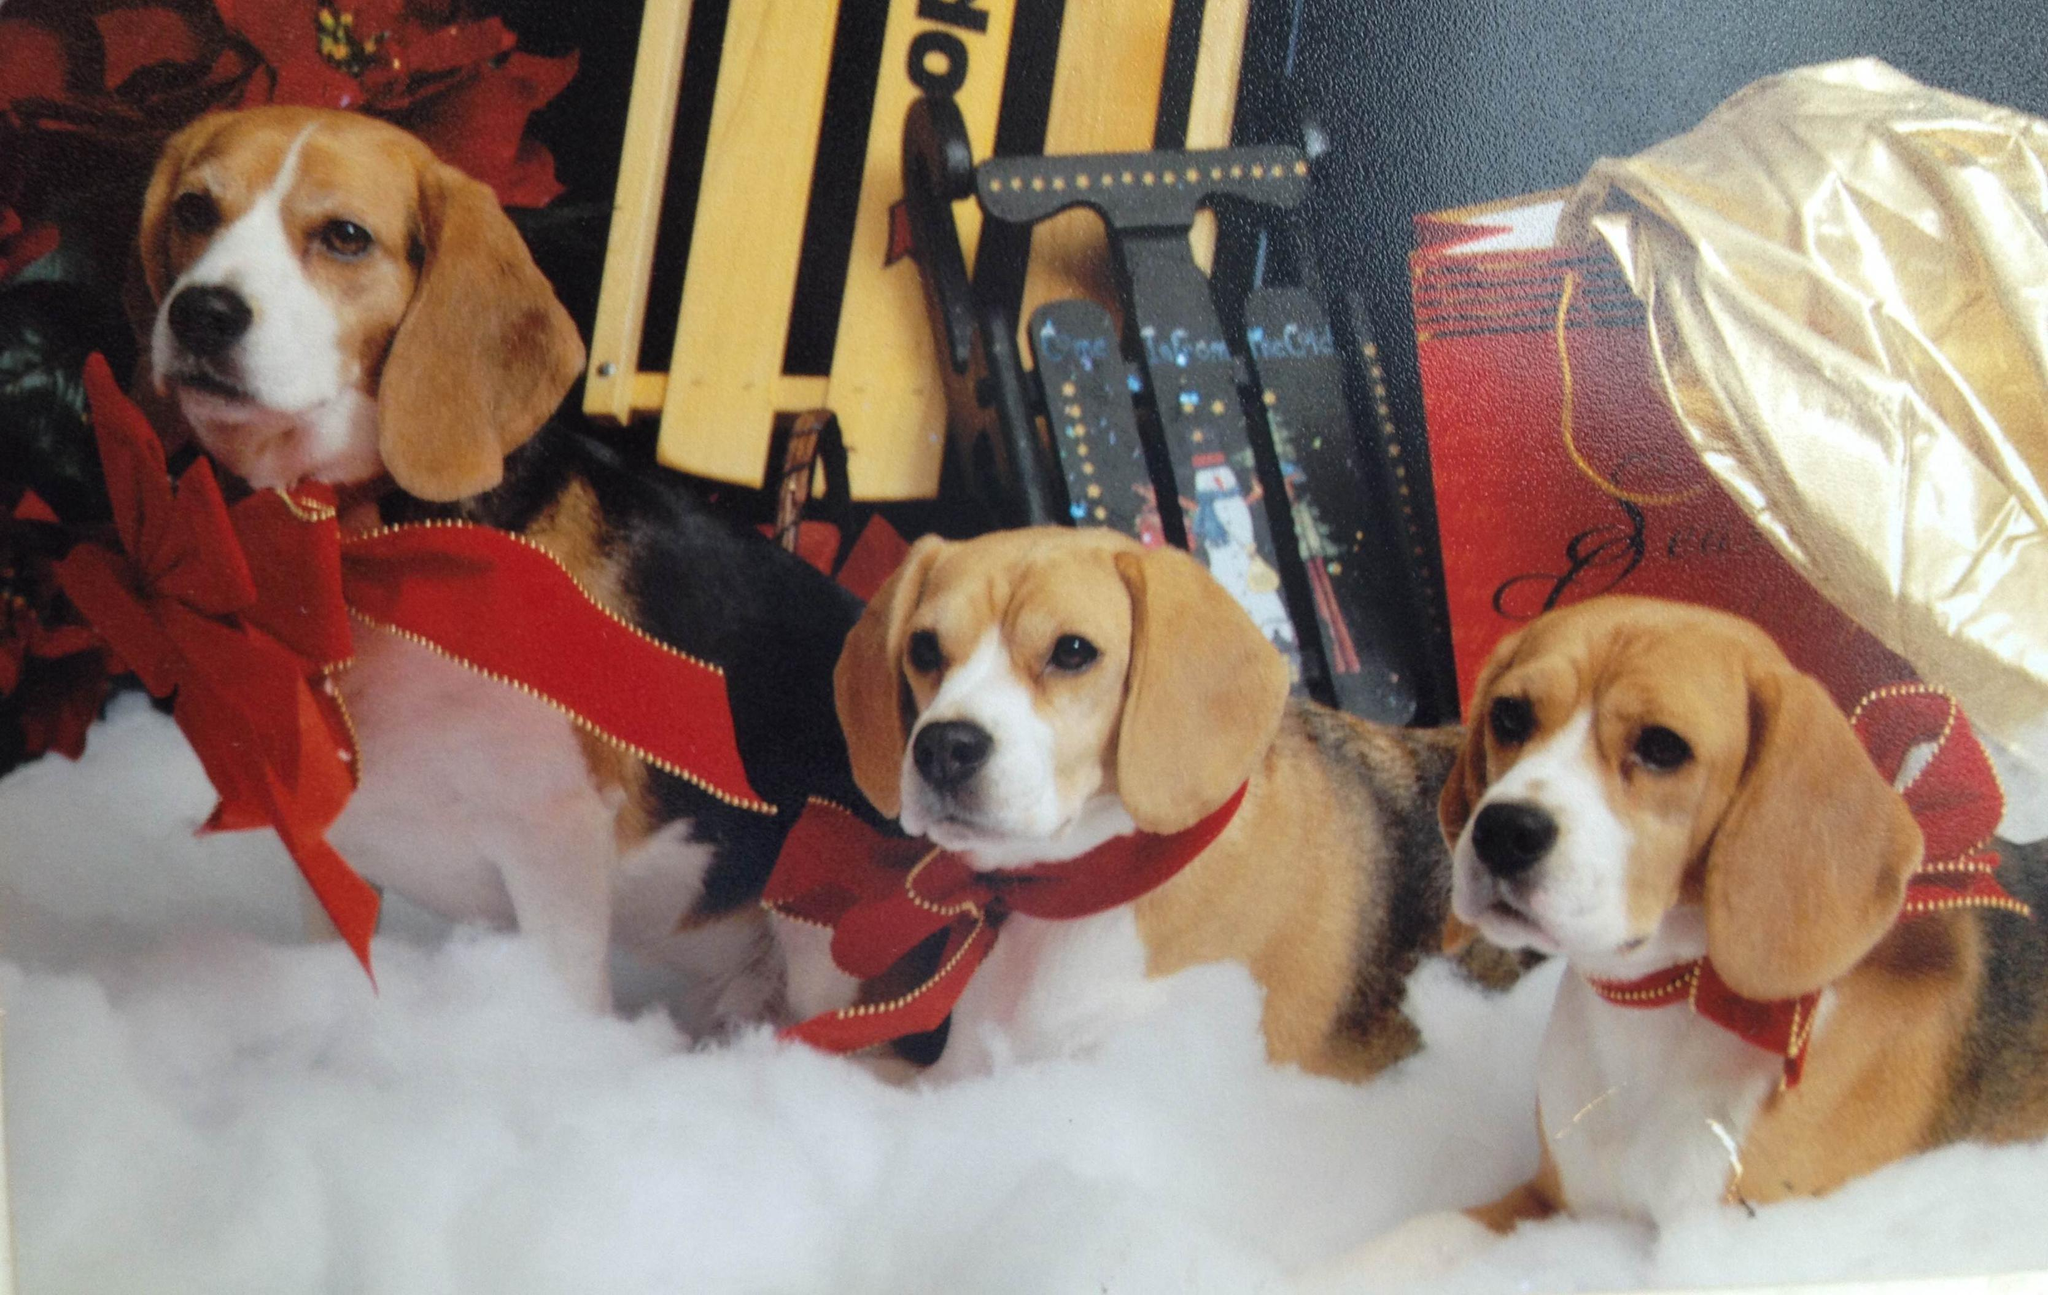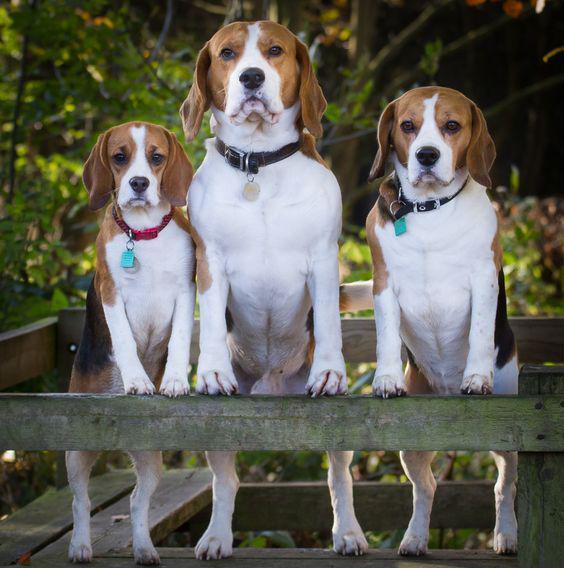The first image is the image on the left, the second image is the image on the right. Evaluate the accuracy of this statement regarding the images: "There are three dogs in the grass in at least one of the images.". Is it true? Answer yes or no. No. The first image is the image on the left, the second image is the image on the right. Given the left and right images, does the statement "One image shows three hounds posed on a rail, with the one in the middle taller than the others, and the other image shows three side-by-side dogs with the leftmost looking taller." hold true? Answer yes or no. Yes. 